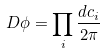<formula> <loc_0><loc_0><loc_500><loc_500>D \phi = \prod _ { i } \frac { d c _ { i } } { 2 \pi }</formula> 